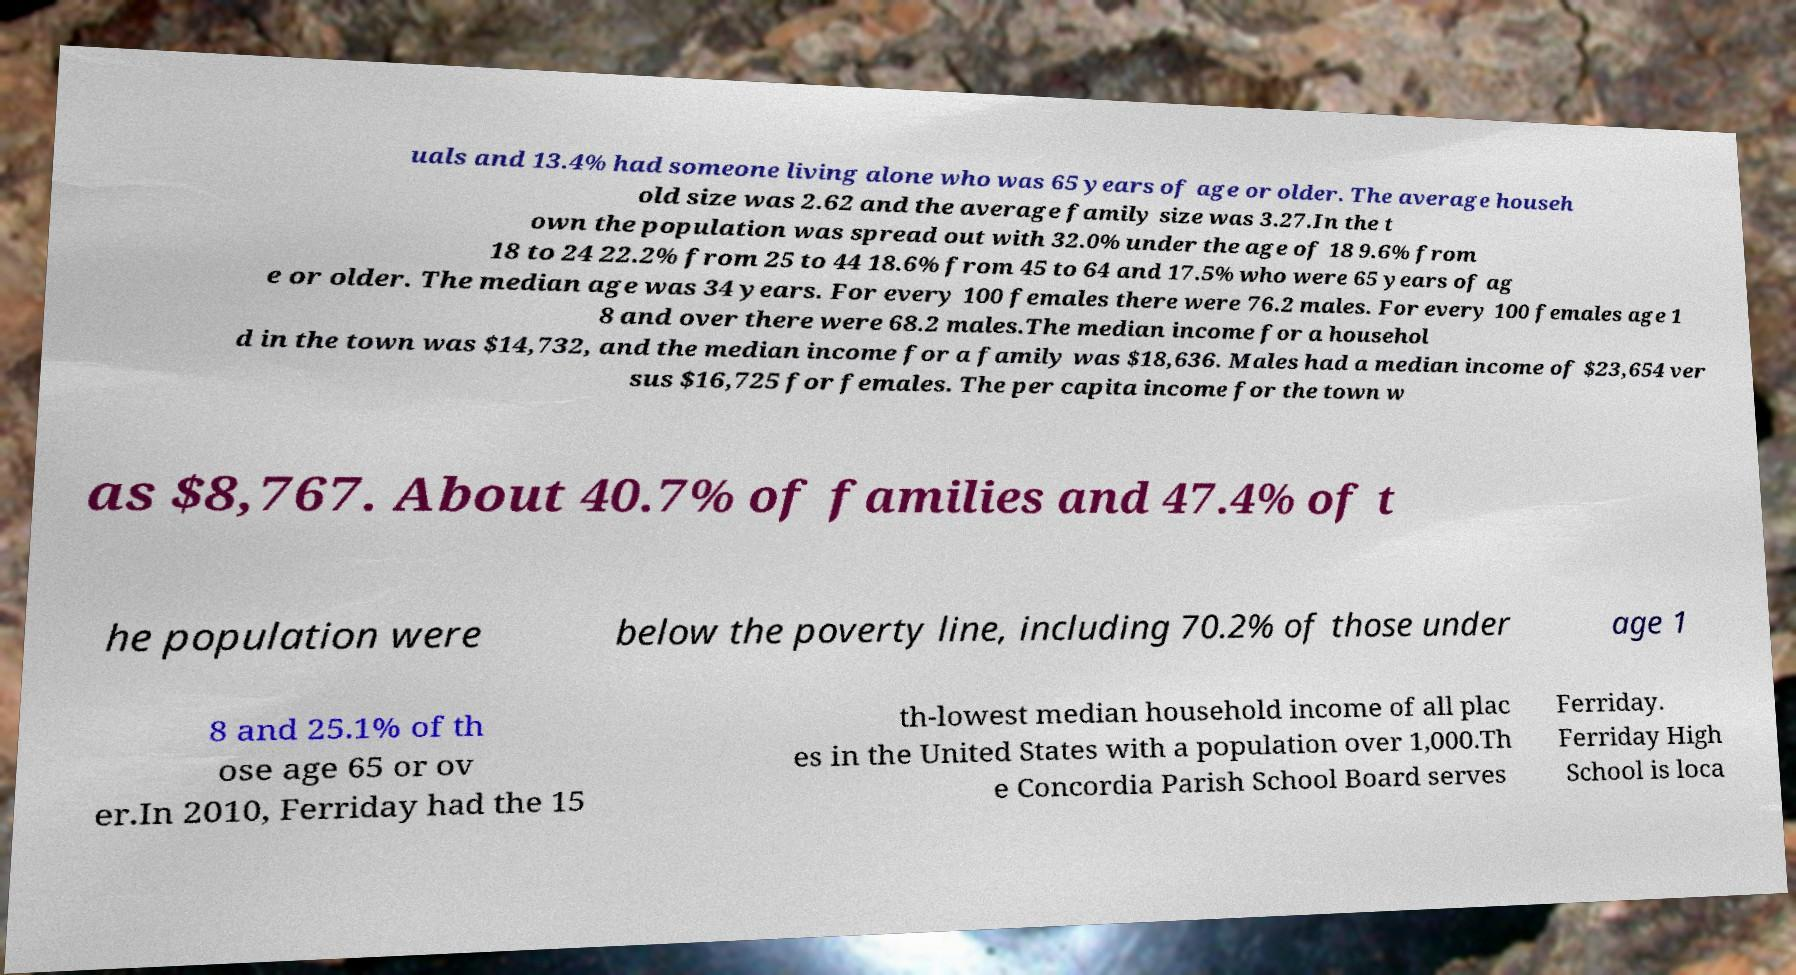Please read and relay the text visible in this image. What does it say? uals and 13.4% had someone living alone who was 65 years of age or older. The average househ old size was 2.62 and the average family size was 3.27.In the t own the population was spread out with 32.0% under the age of 18 9.6% from 18 to 24 22.2% from 25 to 44 18.6% from 45 to 64 and 17.5% who were 65 years of ag e or older. The median age was 34 years. For every 100 females there were 76.2 males. For every 100 females age 1 8 and over there were 68.2 males.The median income for a househol d in the town was $14,732, and the median income for a family was $18,636. Males had a median income of $23,654 ver sus $16,725 for females. The per capita income for the town w as $8,767. About 40.7% of families and 47.4% of t he population were below the poverty line, including 70.2% of those under age 1 8 and 25.1% of th ose age 65 or ov er.In 2010, Ferriday had the 15 th-lowest median household income of all plac es in the United States with a population over 1,000.Th e Concordia Parish School Board serves Ferriday. Ferriday High School is loca 